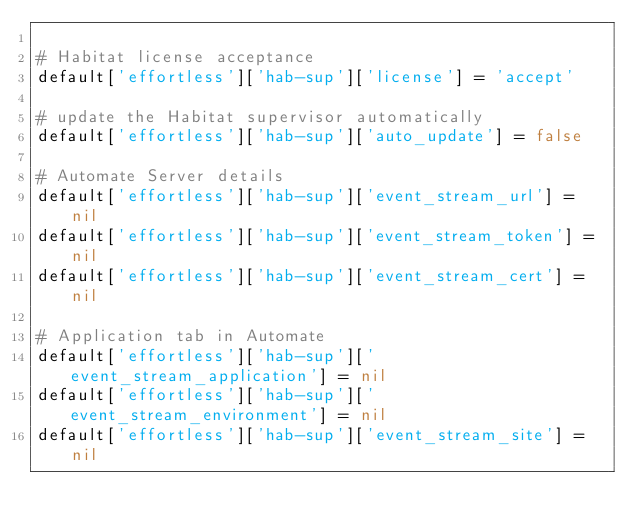<code> <loc_0><loc_0><loc_500><loc_500><_Ruby_>
# Habitat license acceptance
default['effortless']['hab-sup']['license'] = 'accept'

# update the Habitat supervisor automatically
default['effortless']['hab-sup']['auto_update'] = false

# Automate Server details
default['effortless']['hab-sup']['event_stream_url'] = nil
default['effortless']['hab-sup']['event_stream_token'] = nil
default['effortless']['hab-sup']['event_stream_cert'] = nil

# Application tab in Automate
default['effortless']['hab-sup']['event_stream_application'] = nil
default['effortless']['hab-sup']['event_stream_environment'] = nil
default['effortless']['hab-sup']['event_stream_site'] = nil
</code> 